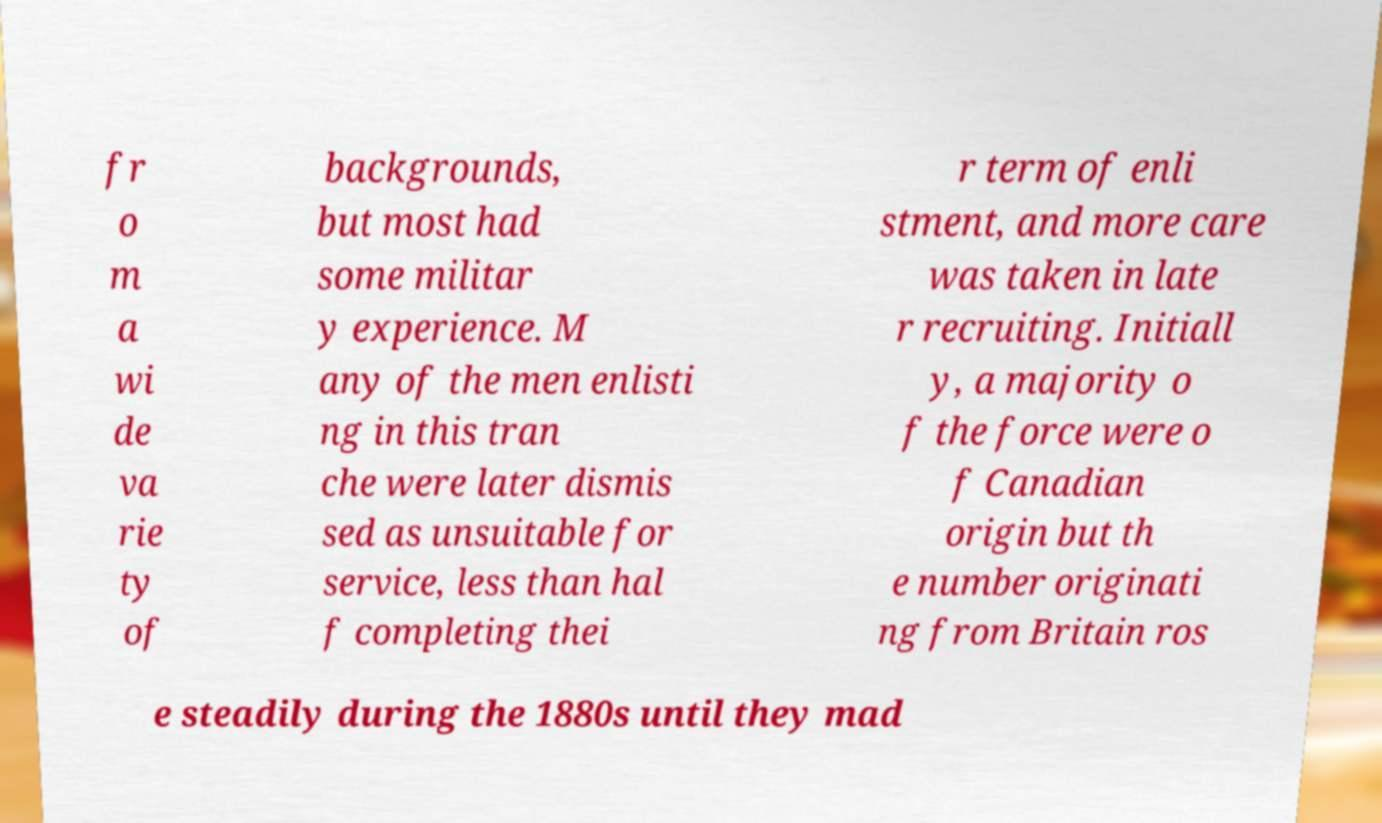Could you extract and type out the text from this image? fr o m a wi de va rie ty of backgrounds, but most had some militar y experience. M any of the men enlisti ng in this tran che were later dismis sed as unsuitable for service, less than hal f completing thei r term of enli stment, and more care was taken in late r recruiting. Initiall y, a majority o f the force were o f Canadian origin but th e number originati ng from Britain ros e steadily during the 1880s until they mad 